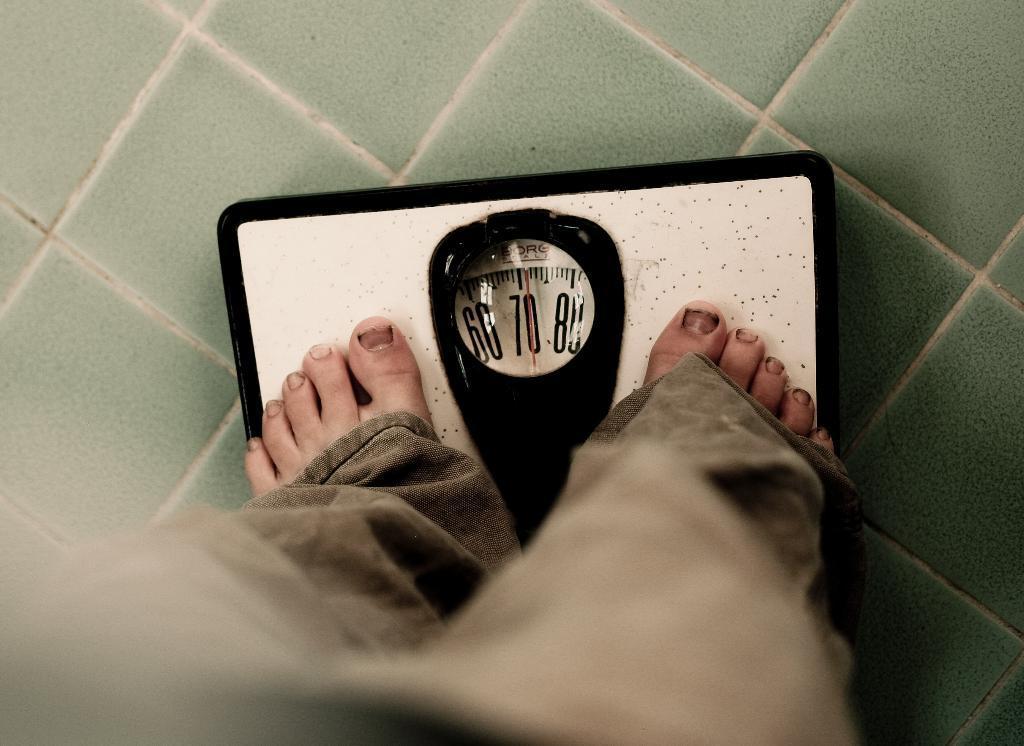Describe this image in one or two sentences. In this picture there is a person standing on a weight machine and the ground is in green color. 